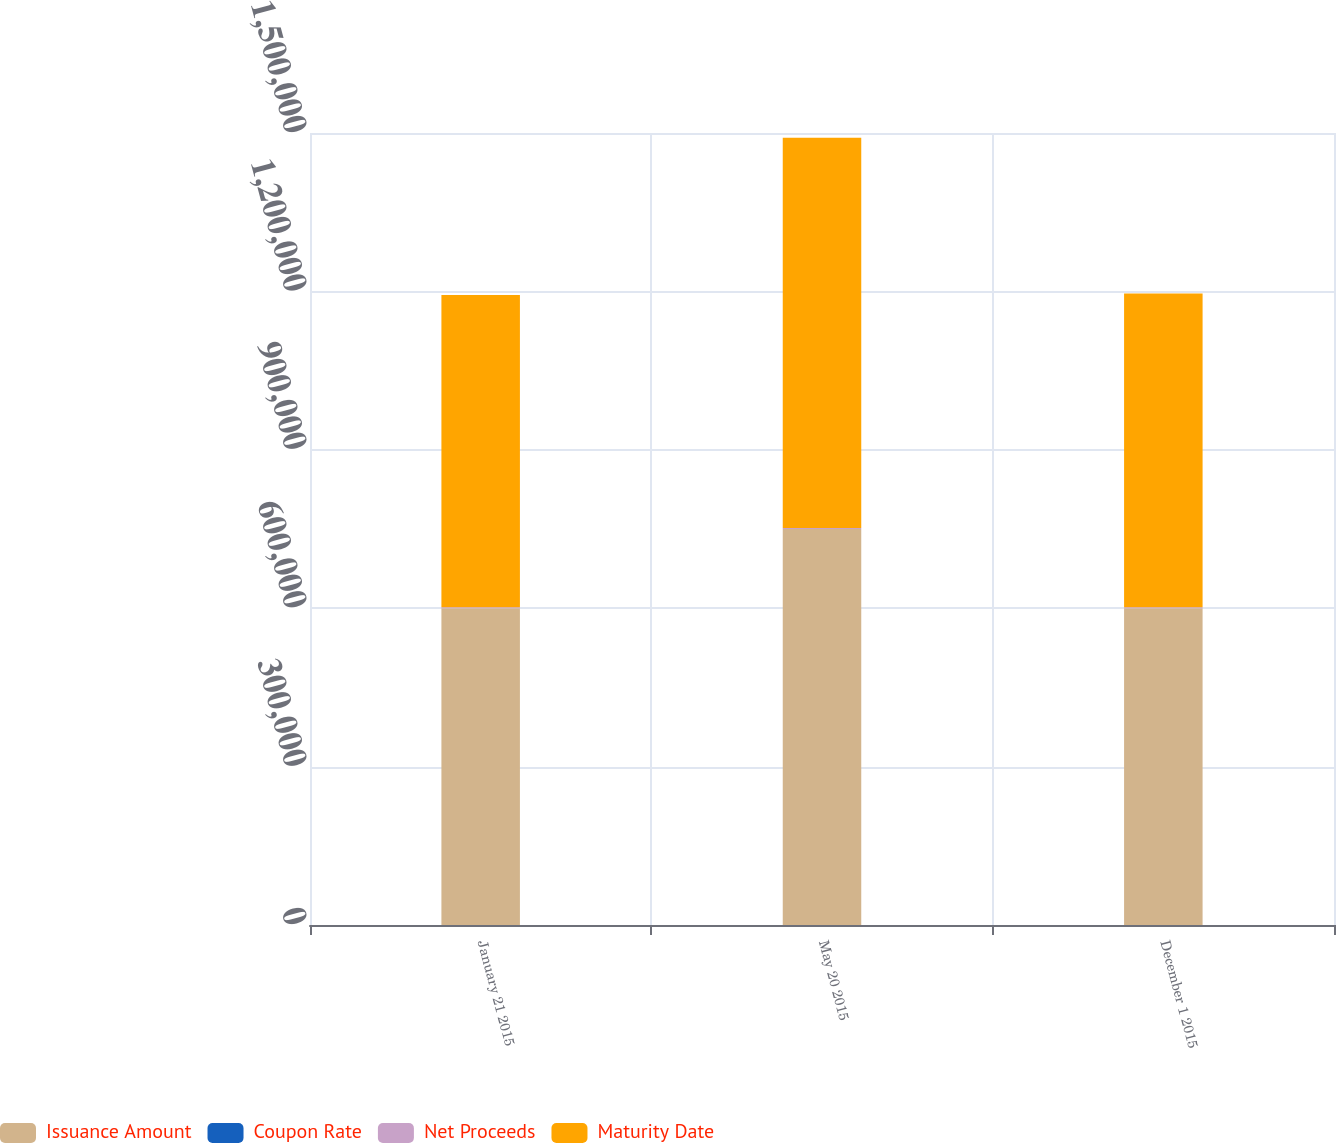Convert chart. <chart><loc_0><loc_0><loc_500><loc_500><stacked_bar_chart><ecel><fcel>January 21 2015<fcel>May 20 2015<fcel>December 1 2015<nl><fcel>Issuance Amount<fcel>600000<fcel>750000<fcel>600000<nl><fcel>Coupon Rate<fcel>3.4<fcel>4<fcel>4<nl><fcel>Net Proceeds<fcel>2025<fcel>2025<fcel>2022<nl><fcel>Maturity Date<fcel>591000<fcel>739000<fcel>594000<nl></chart> 